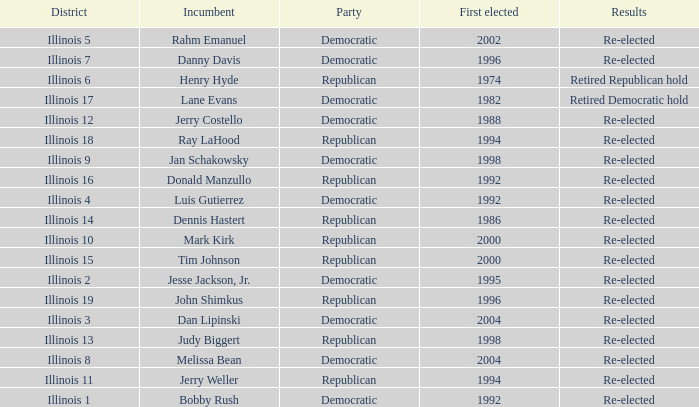What is re-elected Incumbent Jerry Costello's First elected date? 1988.0. 